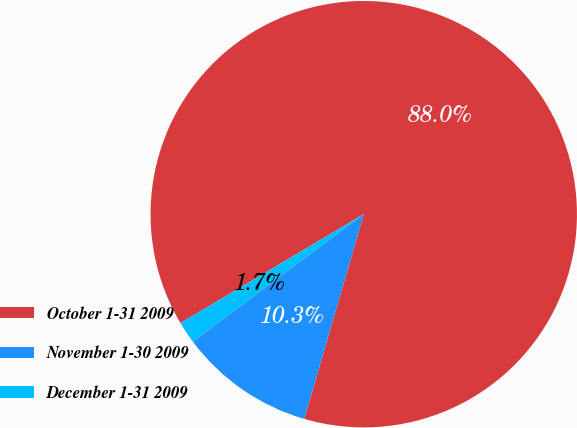<chart> <loc_0><loc_0><loc_500><loc_500><pie_chart><fcel>October 1-31 2009<fcel>November 1-30 2009<fcel>December 1-31 2009<nl><fcel>88.03%<fcel>10.3%<fcel>1.67%<nl></chart> 